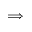<formula> <loc_0><loc_0><loc_500><loc_500>\Longrightarrow</formula> 